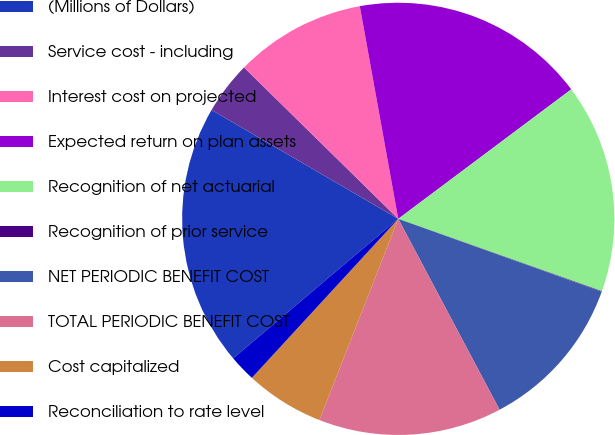Convert chart to OTSL. <chart><loc_0><loc_0><loc_500><loc_500><pie_chart><fcel>(Millions of Dollars)<fcel>Service cost - including<fcel>Interest cost on projected<fcel>Expected return on plan assets<fcel>Recognition of net actuarial<fcel>Recognition of prior service<fcel>NET PERIODIC BENEFIT COST<fcel>TOTAL PERIODIC BENEFIT COST<fcel>Cost capitalized<fcel>Reconciliation to rate level<nl><fcel>19.57%<fcel>3.95%<fcel>9.8%<fcel>17.62%<fcel>15.66%<fcel>0.04%<fcel>11.76%<fcel>13.71%<fcel>5.9%<fcel>1.99%<nl></chart> 